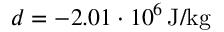<formula> <loc_0><loc_0><loc_500><loc_500>d = - 2 . 0 1 \cdot 1 0 ^ { 6 } \, J / k g</formula> 